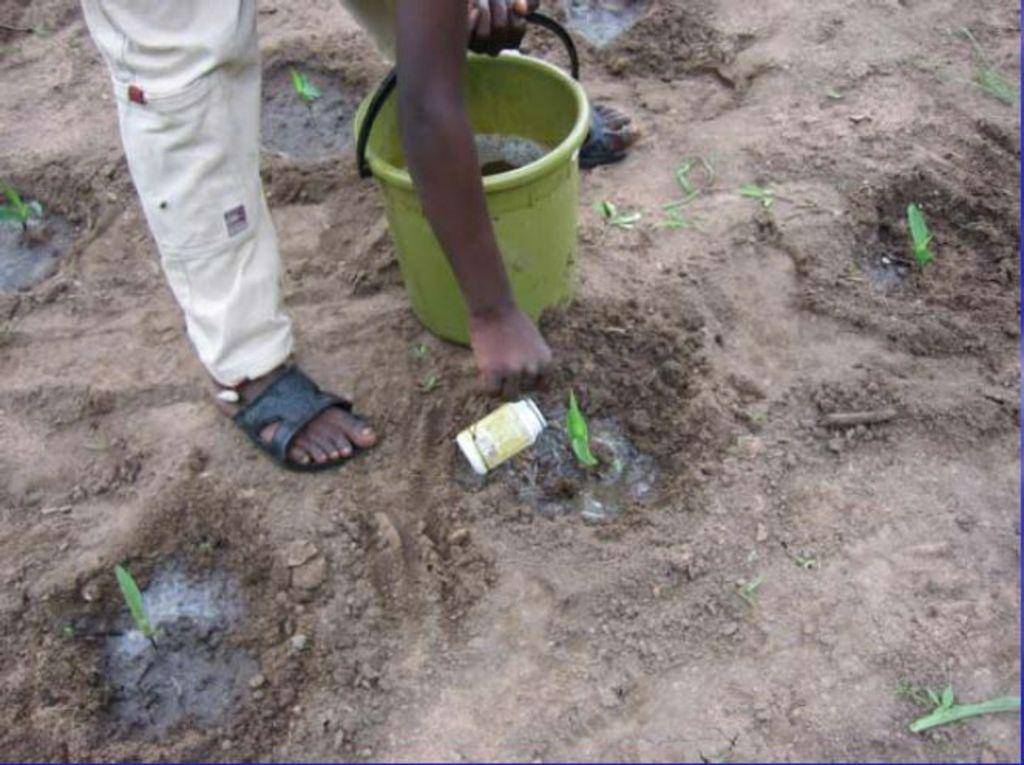What is the person in the image doing? The person is standing in the image and holding a bucket and a bottle. What might the person be using the bucket and bottle for? It is not clear from the image what the person is using the bucket and bottle for, but they could be used for watering plants or cleaning. What type of vegetation is at the bottom of the image? There are plants at the bottom of the image. What is the ground condition in the image? There is mud visible in the image. What type of match can be seen being lit in the image? There is no match present in the image; it only shows a person holding a bucket and a bottle, plants, and mud. 